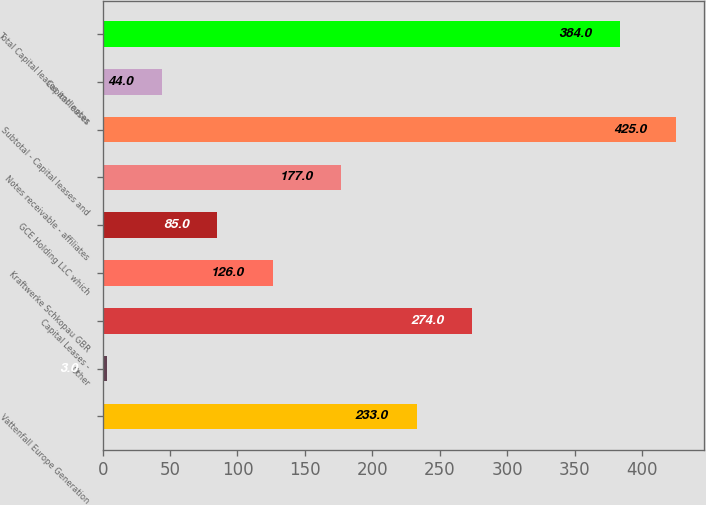Convert chart to OTSL. <chart><loc_0><loc_0><loc_500><loc_500><bar_chart><fcel>Vattenfall Europe Generation<fcel>Other<fcel>Capital Leases -<fcel>Kraftwerke Schkopau GBR<fcel>GCE Holding LLC which<fcel>Notes receivable - affiliates<fcel>Subtotal - Capital leases and<fcel>Capital leases<fcel>Total Capital leases and notes<nl><fcel>233<fcel>3<fcel>274<fcel>126<fcel>85<fcel>177<fcel>425<fcel>44<fcel>384<nl></chart> 